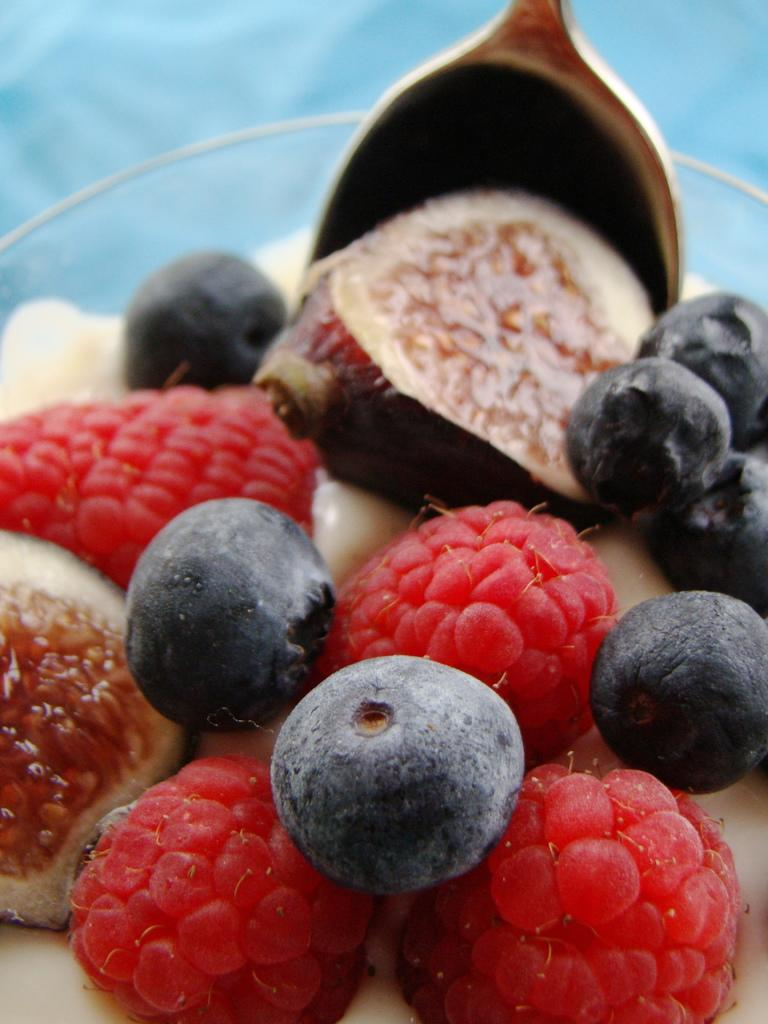What type of fruits can be seen in the image? There are blueberries and litchis in the image, along with other fruits. How are the fruits arranged in the image? The fruits are in a bowl in the image. What utensil is visible in the image? There is a spoon visible in the image. What type of cracker can be seen in the hole in the downtown area in the image? There is no cracker or hole in the downtown area present in the image; it features a bowl of fruits and a spoon. 